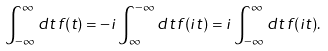Convert formula to latex. <formula><loc_0><loc_0><loc_500><loc_500>\int _ { - \infty } ^ { \infty } d t \, f ( t ) = - i \int _ { \infty } ^ { - \infty } d t \, f ( i t ) = i \int _ { - \infty } ^ { \infty } d t \, f ( i t ) .</formula> 